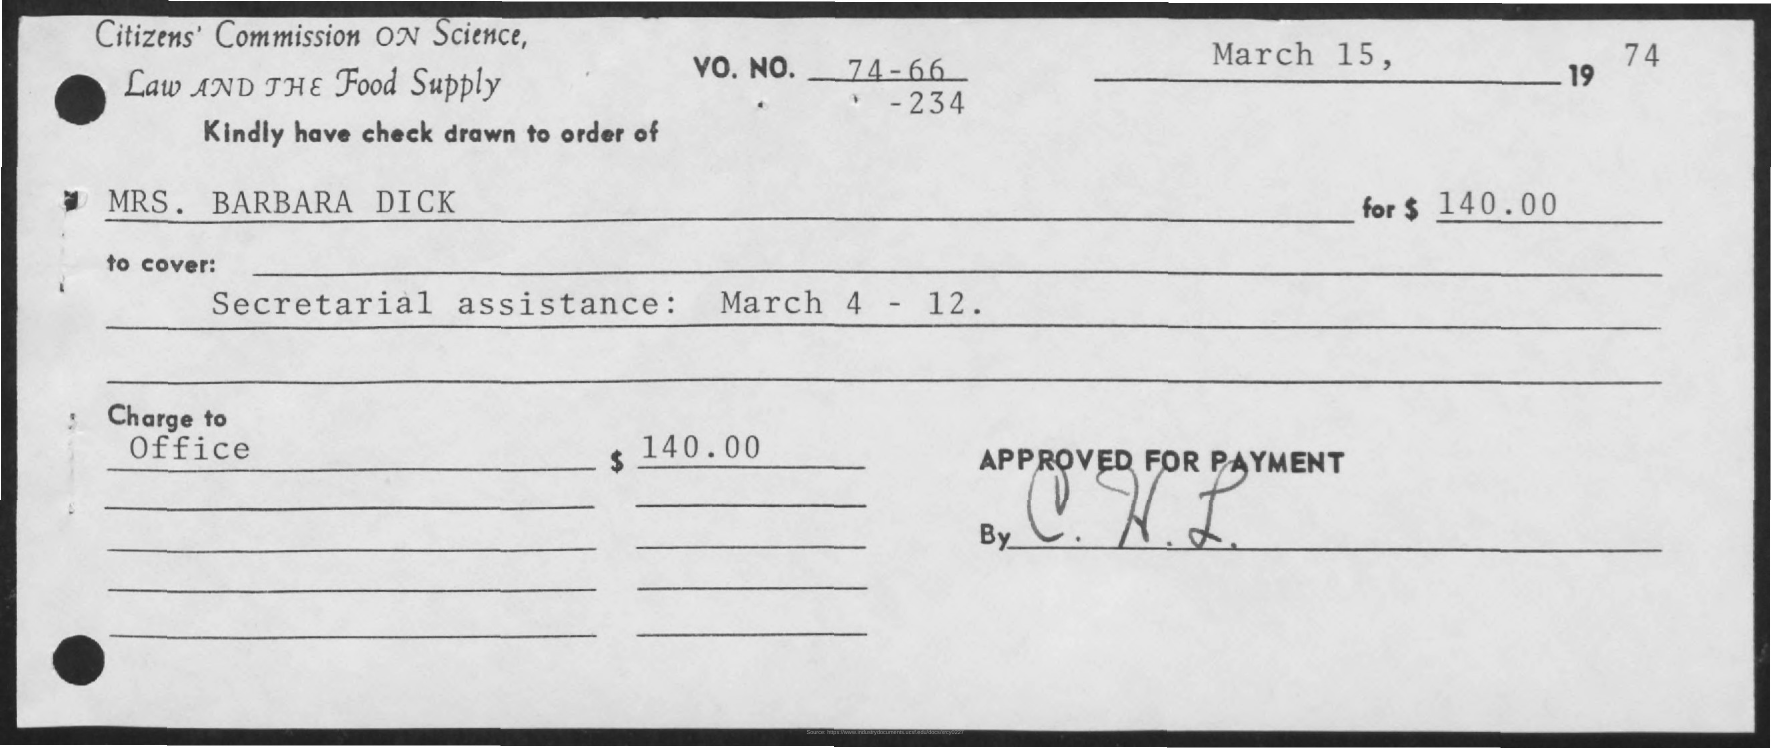Outline some significant characteristics in this image. The date mentioned on the check is March 15, 1974. The check is issued in the name of Mrs. Barbara Dick. I received a check for $140.00. 